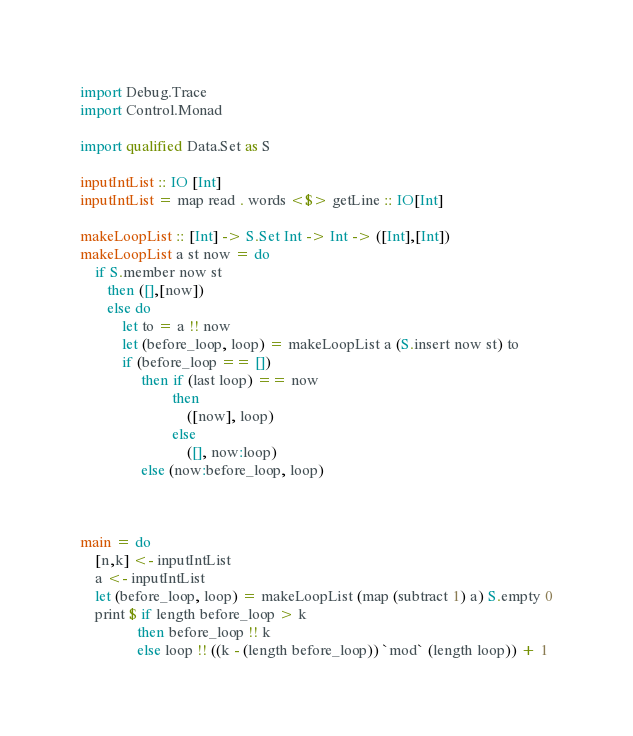<code> <loc_0><loc_0><loc_500><loc_500><_Haskell_>import Debug.Trace
import Control.Monad

import qualified Data.Set as S

inputIntList :: IO [Int]
inputIntList = map read . words <$> getLine :: IO[Int]

makeLoopList :: [Int] -> S.Set Int -> Int -> ([Int],[Int])
makeLoopList a st now = do
    if S.member now st
       then ([],[now])
       else do
           let to = a !! now
           let (before_loop, loop) = makeLoopList a (S.insert now st) to
           if (before_loop == [])
                then if (last loop) == now
                        then 
                            ([now], loop)
                        else 
                            ([], now:loop)
                else (now:before_loop, loop) 

    

main = do
    [n,k] <- inputIntList
    a <- inputIntList
    let (before_loop, loop) = makeLoopList (map (subtract 1) a) S.empty 0
    print $ if length before_loop > k
               then before_loop !! k
               else loop !! ((k - (length before_loop)) `mod` (length loop)) + 1
</code> 